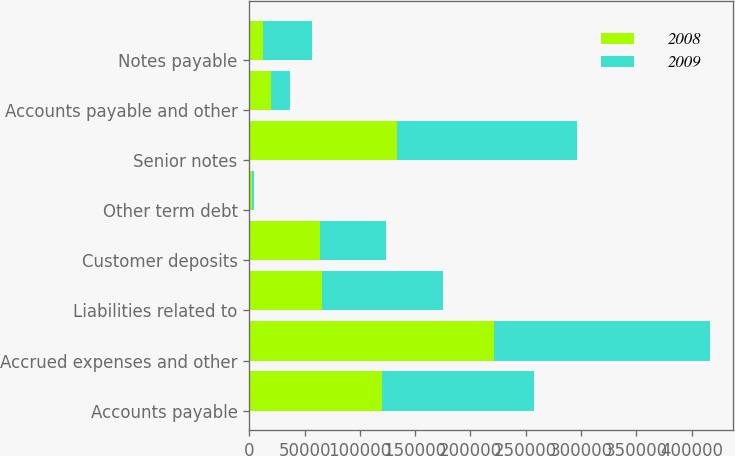<chart> <loc_0><loc_0><loc_500><loc_500><stacked_bar_chart><ecel><fcel>Accounts payable<fcel>Accrued expenses and other<fcel>Liabilities related to<fcel>Customer deposits<fcel>Other term debt<fcel>Senior notes<fcel>Accounts payable and other<fcel>Notes payable<nl><fcel>2008<fcel>120464<fcel>221352<fcel>65915<fcel>63591<fcel>2166<fcel>133370<fcel>19306<fcel>12344<nl><fcel>2009<fcel>137285<fcel>194869<fcel>109439<fcel>59623<fcel>2530<fcel>163320<fcel>17842<fcel>44539<nl></chart> 